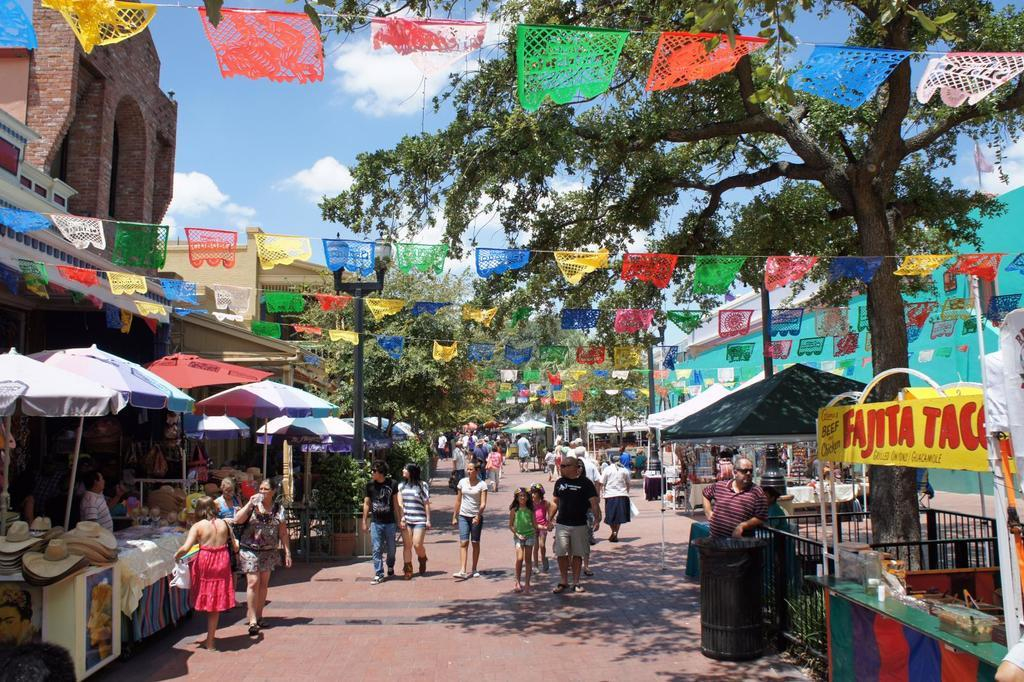What type of structures can be seen in the image? There are stalls in the image. What are the people in the image doing? People are walking on the road in the image. What are the light poles used for in the image? The light poles provide illumination in the image. What type of vegetation is present in the image? Trees are present in the image. What type of decorative objects can be seen in the image? Flags are visible in the image. What is visible in the background of the image? The sky is visible in the image, and clouds are present. Can you tell me how many hydrants are visible in the image? There are no hydrants present in the image. What type of plane is flying over the stalls in the image? There is no plane visible in the image; only stalls, people, light poles, trees, flags, and the sky are present. 